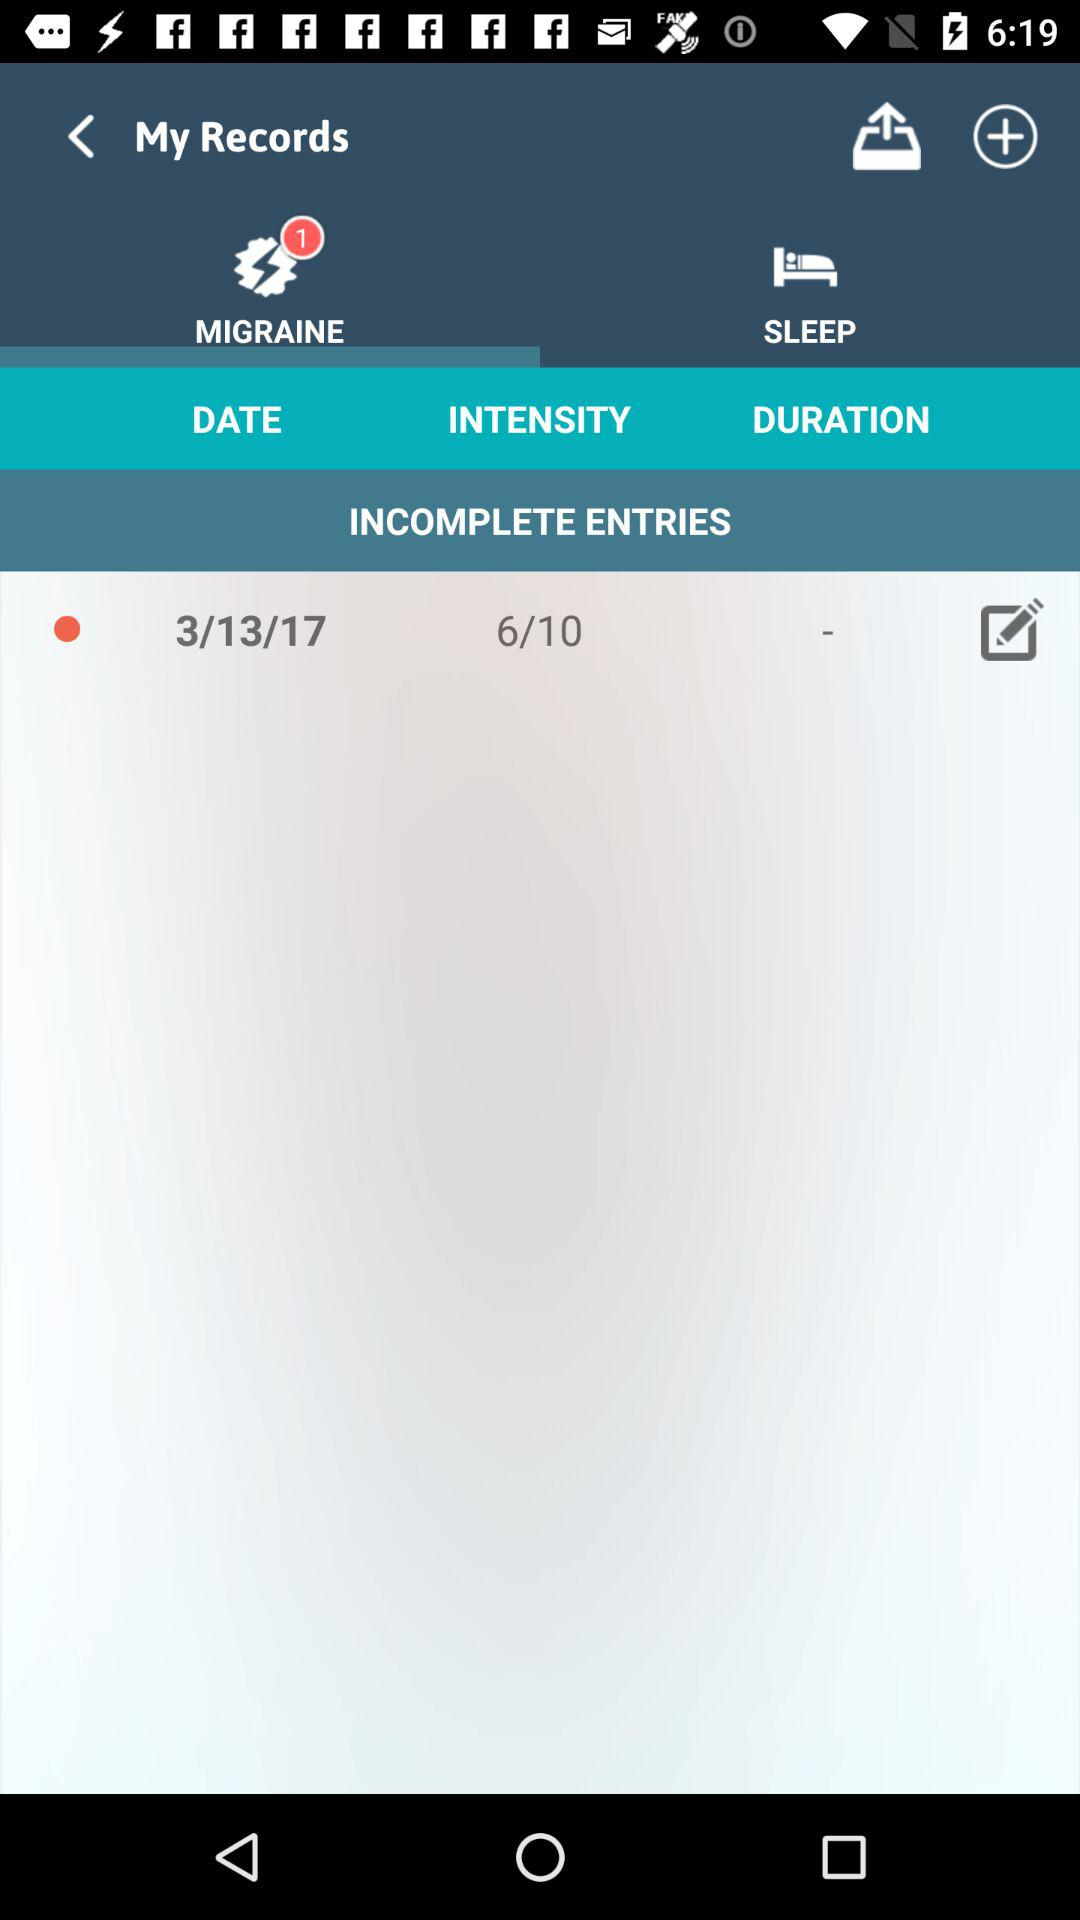What is the date? The date is March 13, 2017. 